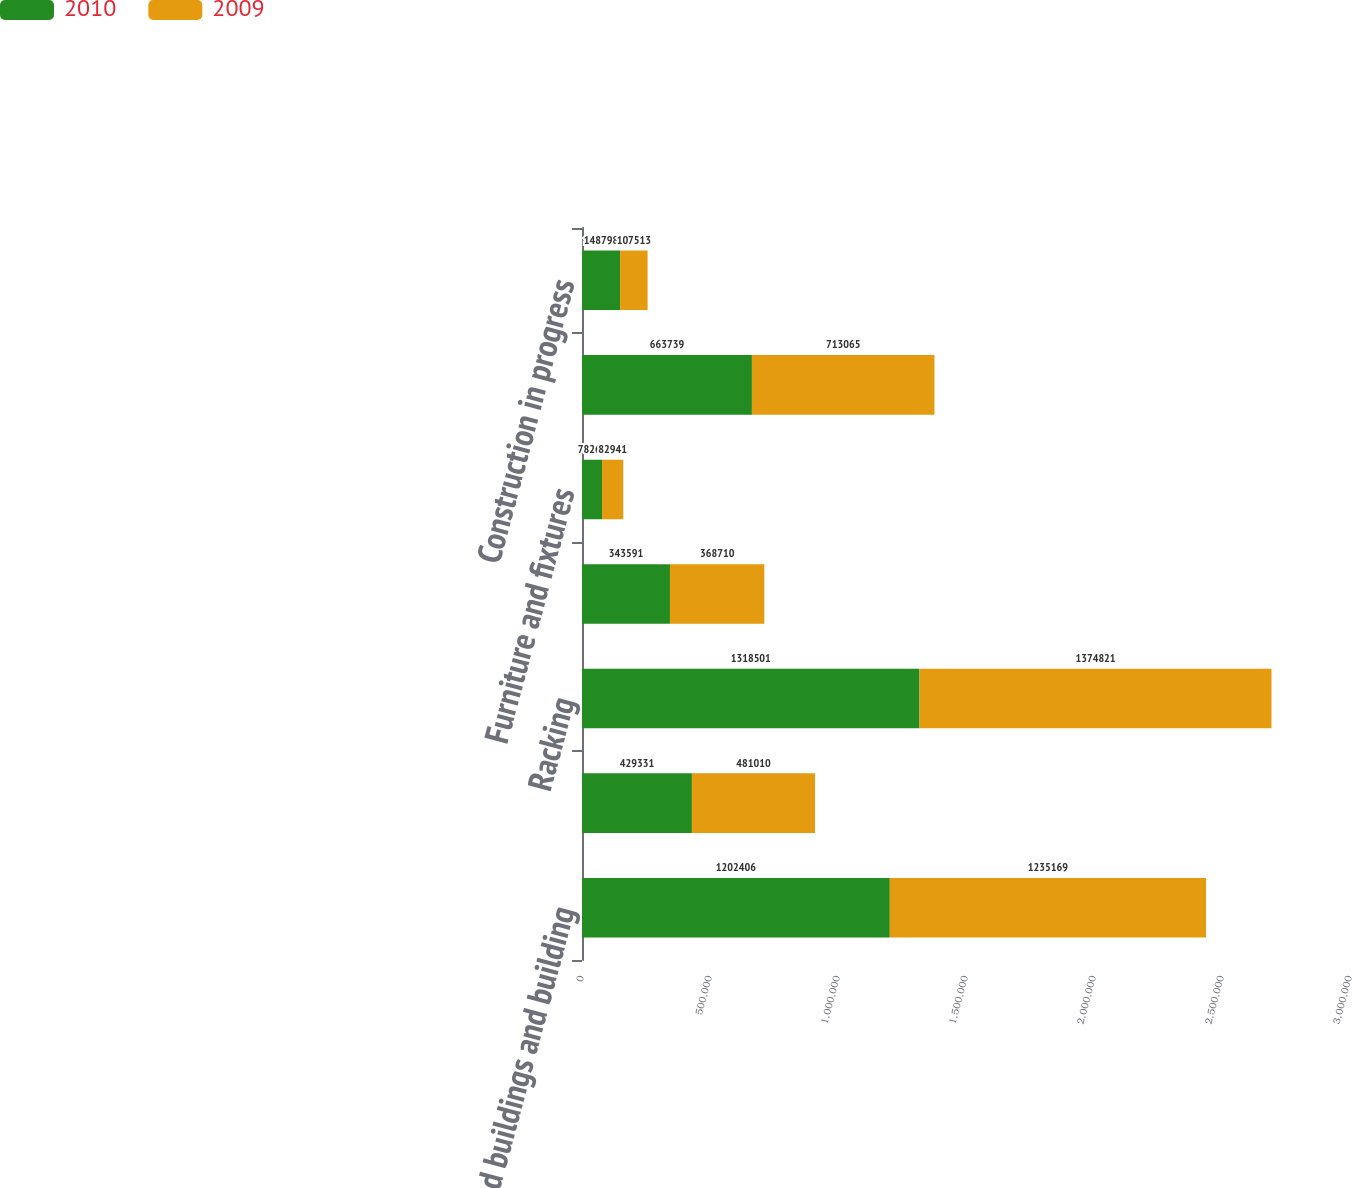<chart> <loc_0><loc_0><loc_500><loc_500><stacked_bar_chart><ecel><fcel>Land buildings and building<fcel>Leasehold improvements<fcel>Racking<fcel>Warehouse equipment/vehicles<fcel>Furniture and fixtures<fcel>Computer hardware and software<fcel>Construction in progress<nl><fcel>2010<fcel>1.20241e+06<fcel>429331<fcel>1.3185e+06<fcel>343591<fcel>78265<fcel>663739<fcel>148798<nl><fcel>2009<fcel>1.23517e+06<fcel>481010<fcel>1.37482e+06<fcel>368710<fcel>82941<fcel>713065<fcel>107513<nl></chart> 